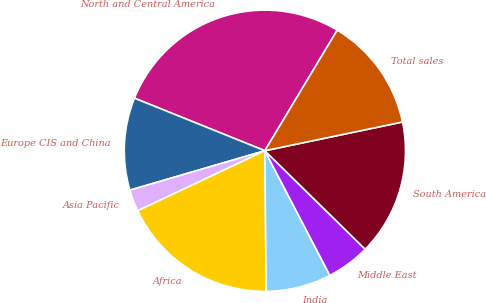Convert chart. <chart><loc_0><loc_0><loc_500><loc_500><pie_chart><fcel>North and Central America<fcel>Europe CIS and China<fcel>Asia Pacific<fcel>Africa<fcel>India<fcel>Middle East<fcel>South America<fcel>Total sales<nl><fcel>27.5%<fcel>10.62%<fcel>2.5%<fcel>18.12%<fcel>7.5%<fcel>5.0%<fcel>15.62%<fcel>13.12%<nl></chart> 